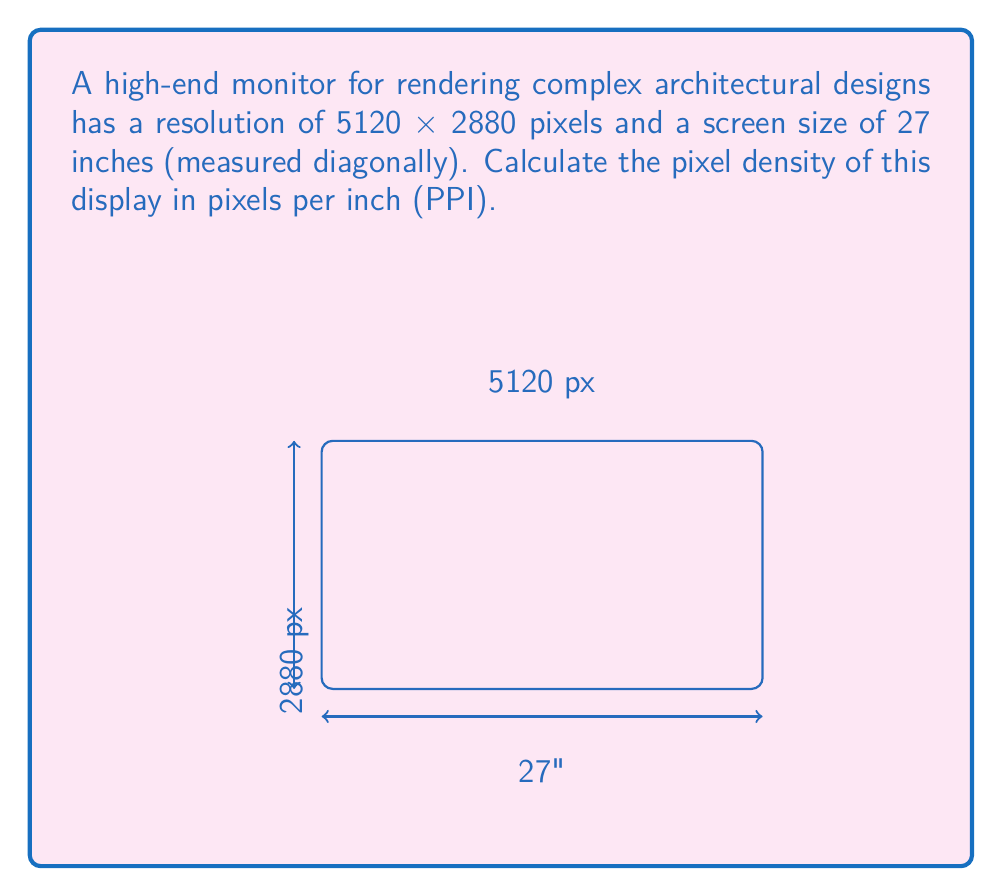Can you solve this math problem? To calculate the pixel density (PPI), we need to follow these steps:

1. Calculate the width (w) and height (h) of the screen in pixels:
   w = 5120 px, h = 2880 px

2. Calculate the diagonal resolution in pixels using the Pythagorean theorem:
   $$d_{px} = \sqrt{w^2 + h^2} = \sqrt{5120^2 + 2880^2} = 5880 \text{ px}$$

3. Convert the diagonal screen size from inches to pixels:
   $$d_{in} = 27 \text{ inches}$$

4. Calculate PPI by dividing the diagonal resolution in pixels by the diagonal size in inches:
   $$PPI = \frac{d_{px}}{d_{in}} = \frac{5880}{27} \approx 217.78$$

5. Round to the nearest whole number:
   PPI ≈ 218
Answer: 218 PPI 